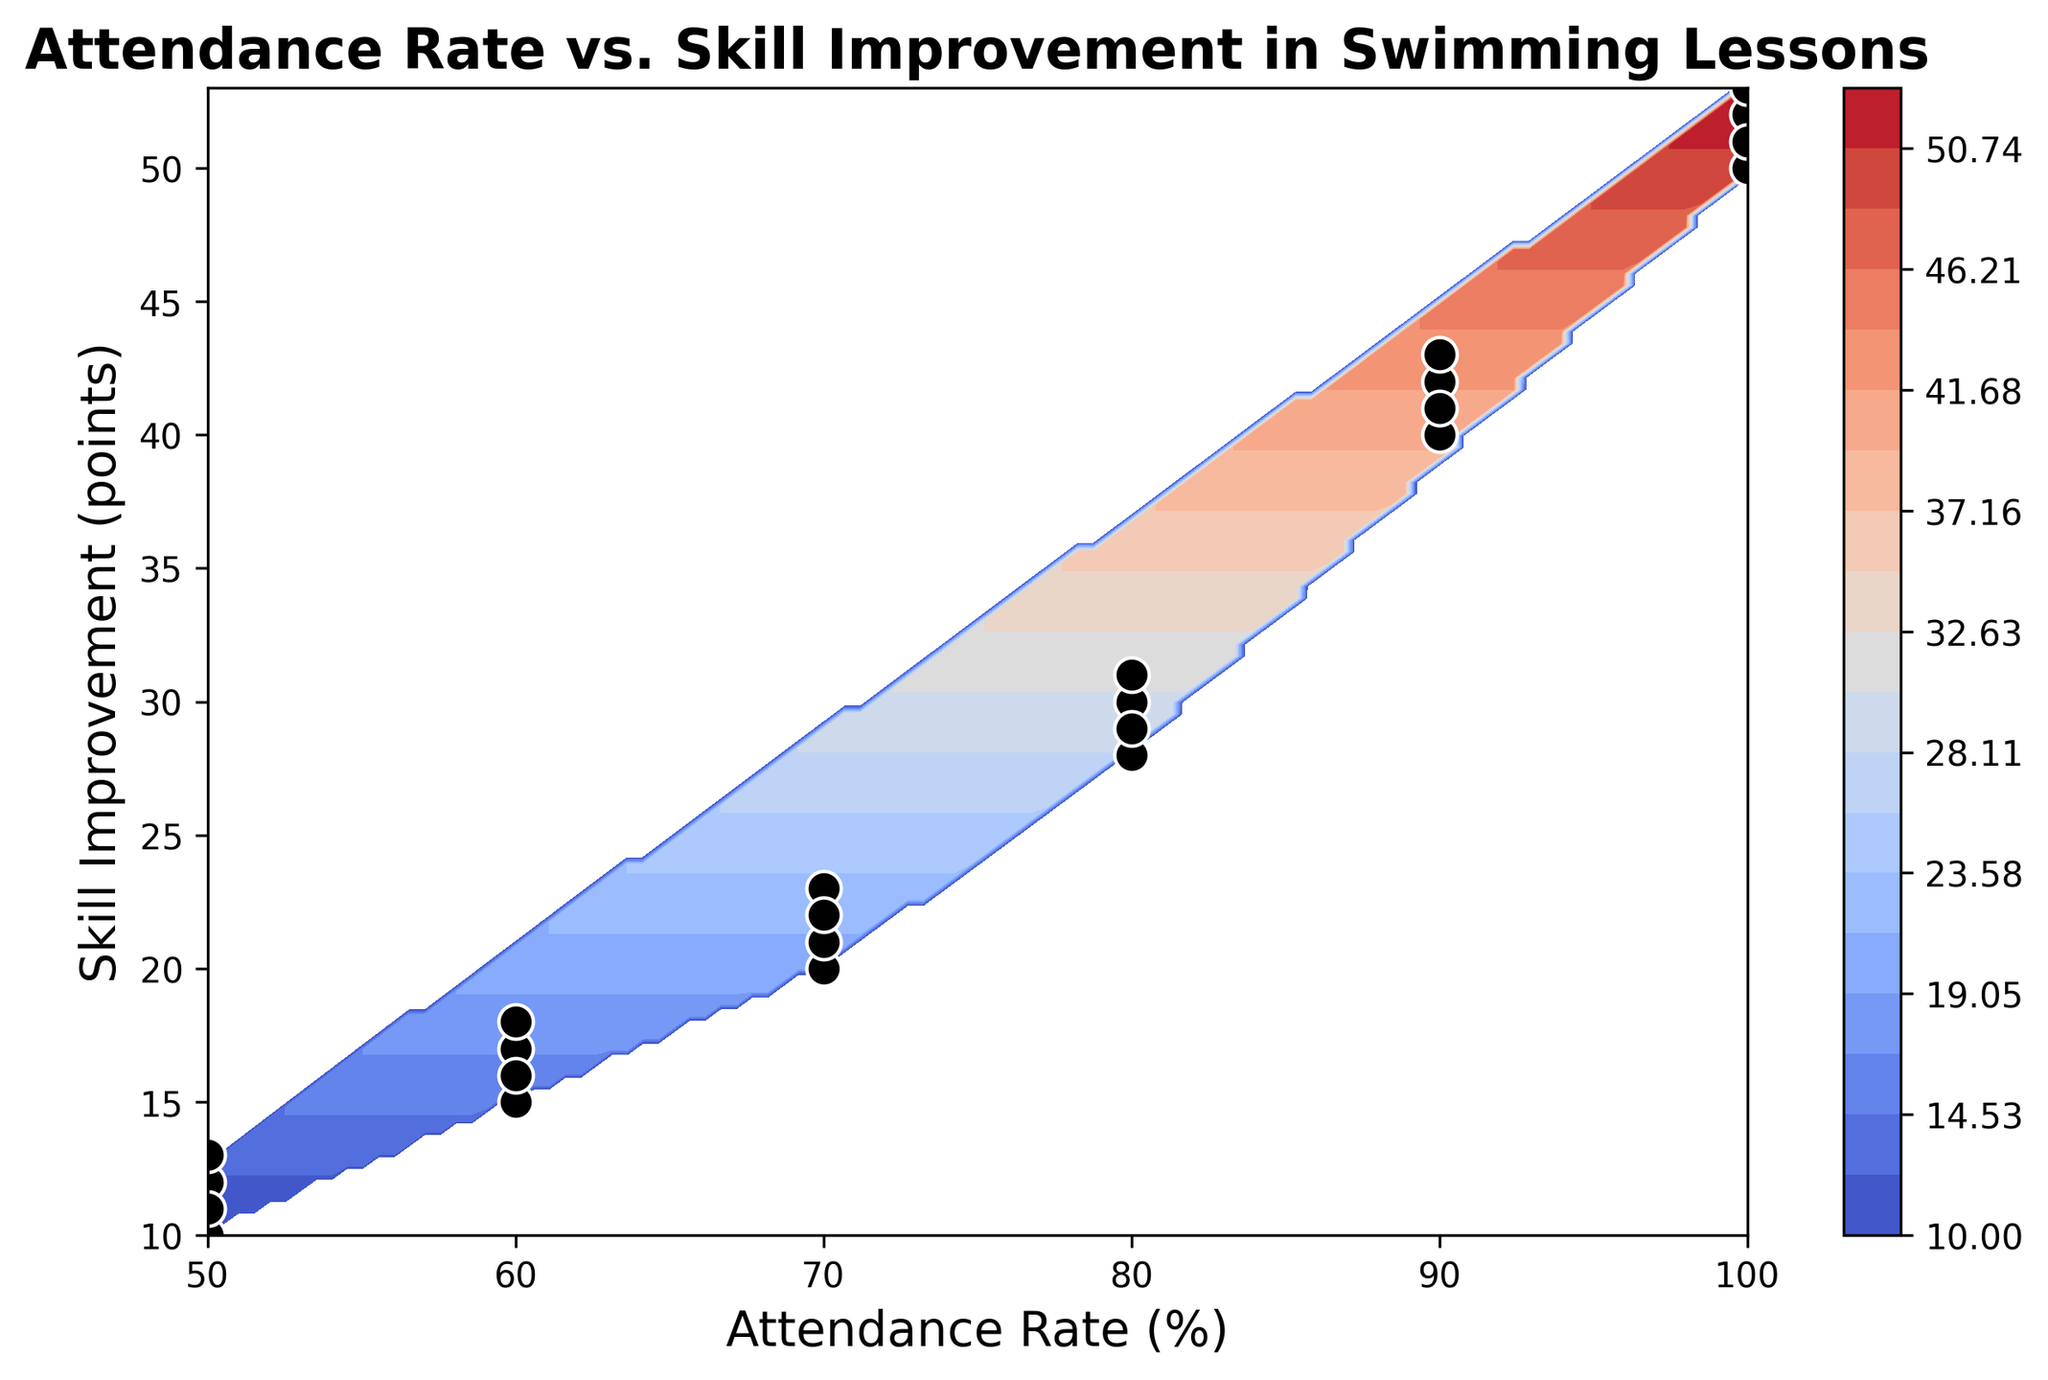what is the maximum skill improvement observed at 90% attendance? By examining the figure, the maximum skill improvement at 90% attendance can be identified by looking at the highest skill improvement point within the 90% attendance data points.
Answer: 43 Is the improvement in skills faster when attendance is above 70%? We can observe the color gradient change above the 70% attendance rate where the skill improvement points steeply incline into higher values. This indicates a faster rate of skill improvement.
Answer: Yes Around which attendance rate do we see the largest jump in skill improvement? The contour lines on the plot will be closely packed where the largest skill improvement jump occurs. In this plot, the most significant jump seems to happen from 70% to 80% attendance.
Answer: 70% to 80% How many distinct attendance levels are shown with data points on the plot? The scatter plot overlay reveals distinct black dots with the white edge overlays for different attendance levels: 50%, 60%, 70%, 80%, 90%, and 100%.
Answer: 6 What should be the target attendance to achieve a skill improvement between 40 and 50 points? Looking at the color gradient and scatter points, skill improvement between 40 and 50 points corresponds approximately to attendance levels between 90% and 100%.
Answer: 90%-100% By how much does the skill improvement increase from 80% to 100% attendance? From the scatter points, the skill improvement at 80% attendance ranges between 28-31 points, and at 100% attendance it ranges between 50-53 points. We can calculate the difference as an average increase of around 20 points.
Answer: about 20 points For attendance rate of 50%, what is the range of skill improvement? Points at the 50% attendance rate show a range of skill improvements from 10 to 13 points. This range can be visually confirmed by identifying minimum and maximum levels within that attendance rate.
Answer: 10-13 points 